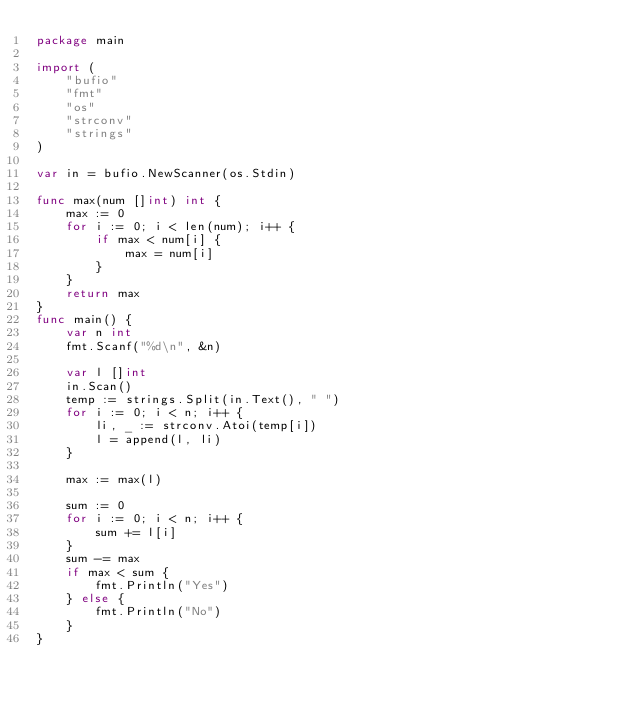Convert code to text. <code><loc_0><loc_0><loc_500><loc_500><_Go_>package main

import (
	"bufio"
	"fmt"
	"os"
	"strconv"
	"strings"
)

var in = bufio.NewScanner(os.Stdin)

func max(num []int) int {
	max := 0
	for i := 0; i < len(num); i++ {
		if max < num[i] {
			max = num[i]
		}
	}
	return max
}
func main() {
	var n int
	fmt.Scanf("%d\n", &n)

	var l []int
	in.Scan()
	temp := strings.Split(in.Text(), " ")
	for i := 0; i < n; i++ {
		li, _ := strconv.Atoi(temp[i])
		l = append(l, li)
	}

	max := max(l)

	sum := 0
	for i := 0; i < n; i++ {
		sum += l[i]
	}
	sum -= max
	if max < sum {
		fmt.Println("Yes")
	} else {
		fmt.Println("No")
	}
}</code> 